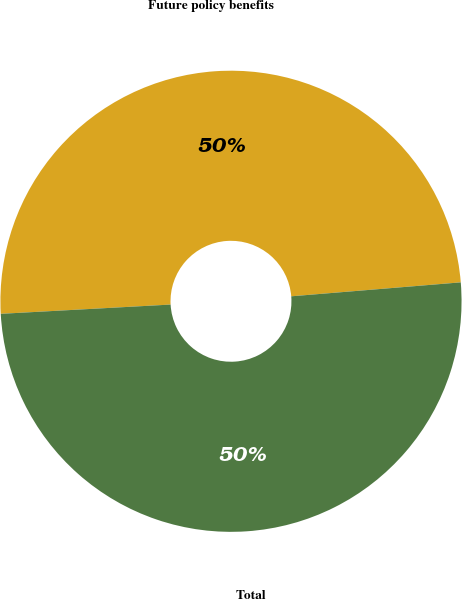<chart> <loc_0><loc_0><loc_500><loc_500><pie_chart><fcel>Future policy benefits<fcel>Total<nl><fcel>49.56%<fcel>50.44%<nl></chart> 